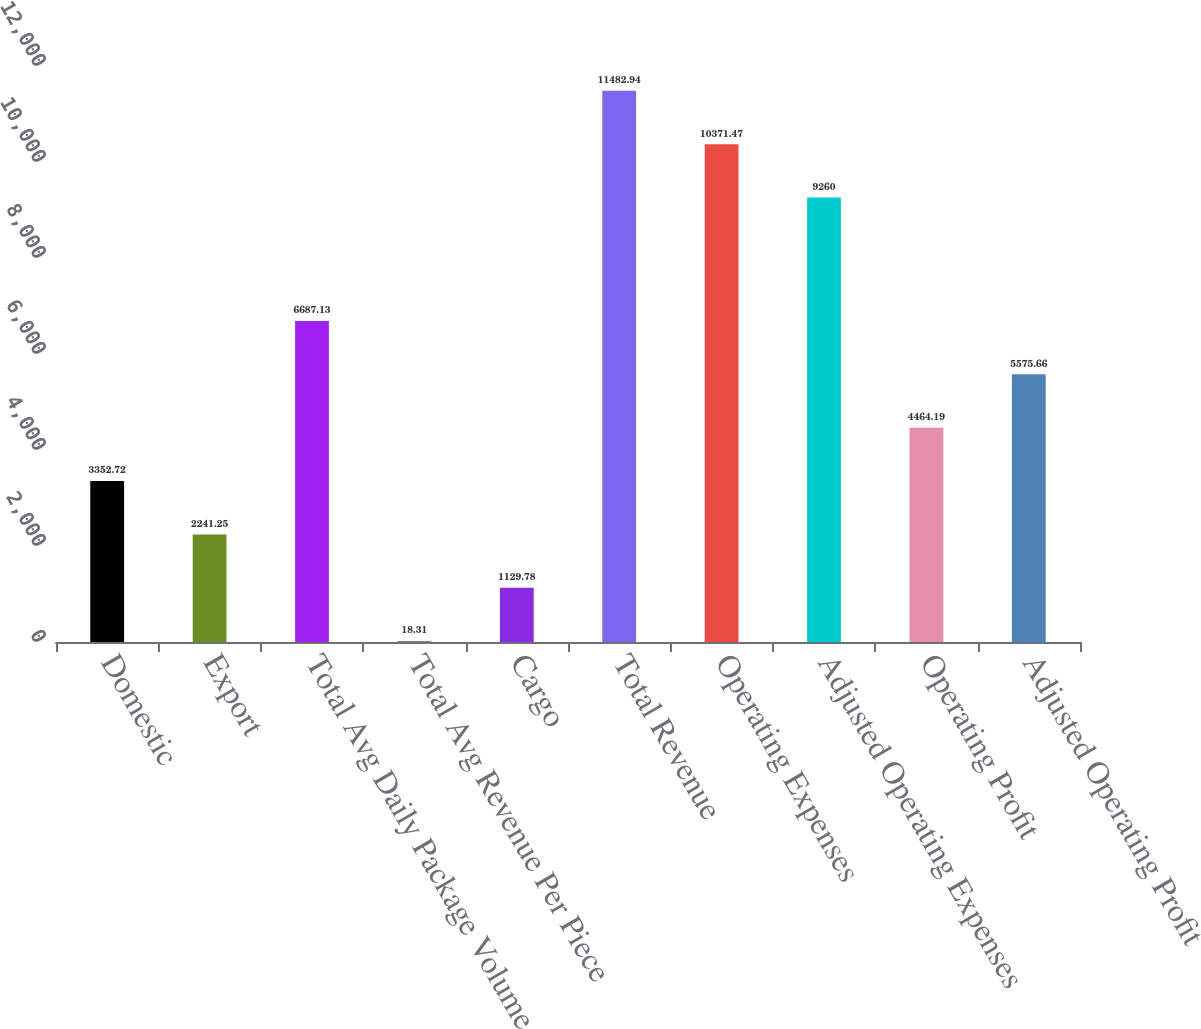Convert chart. <chart><loc_0><loc_0><loc_500><loc_500><bar_chart><fcel>Domestic<fcel>Export<fcel>Total Avg Daily Package Volume<fcel>Total Avg Revenue Per Piece<fcel>Cargo<fcel>Total Revenue<fcel>Operating Expenses<fcel>Adjusted Operating Expenses<fcel>Operating Profit<fcel>Adjusted Operating Profit<nl><fcel>3352.72<fcel>2241.25<fcel>6687.13<fcel>18.31<fcel>1129.78<fcel>11482.9<fcel>10371.5<fcel>9260<fcel>4464.19<fcel>5575.66<nl></chart> 